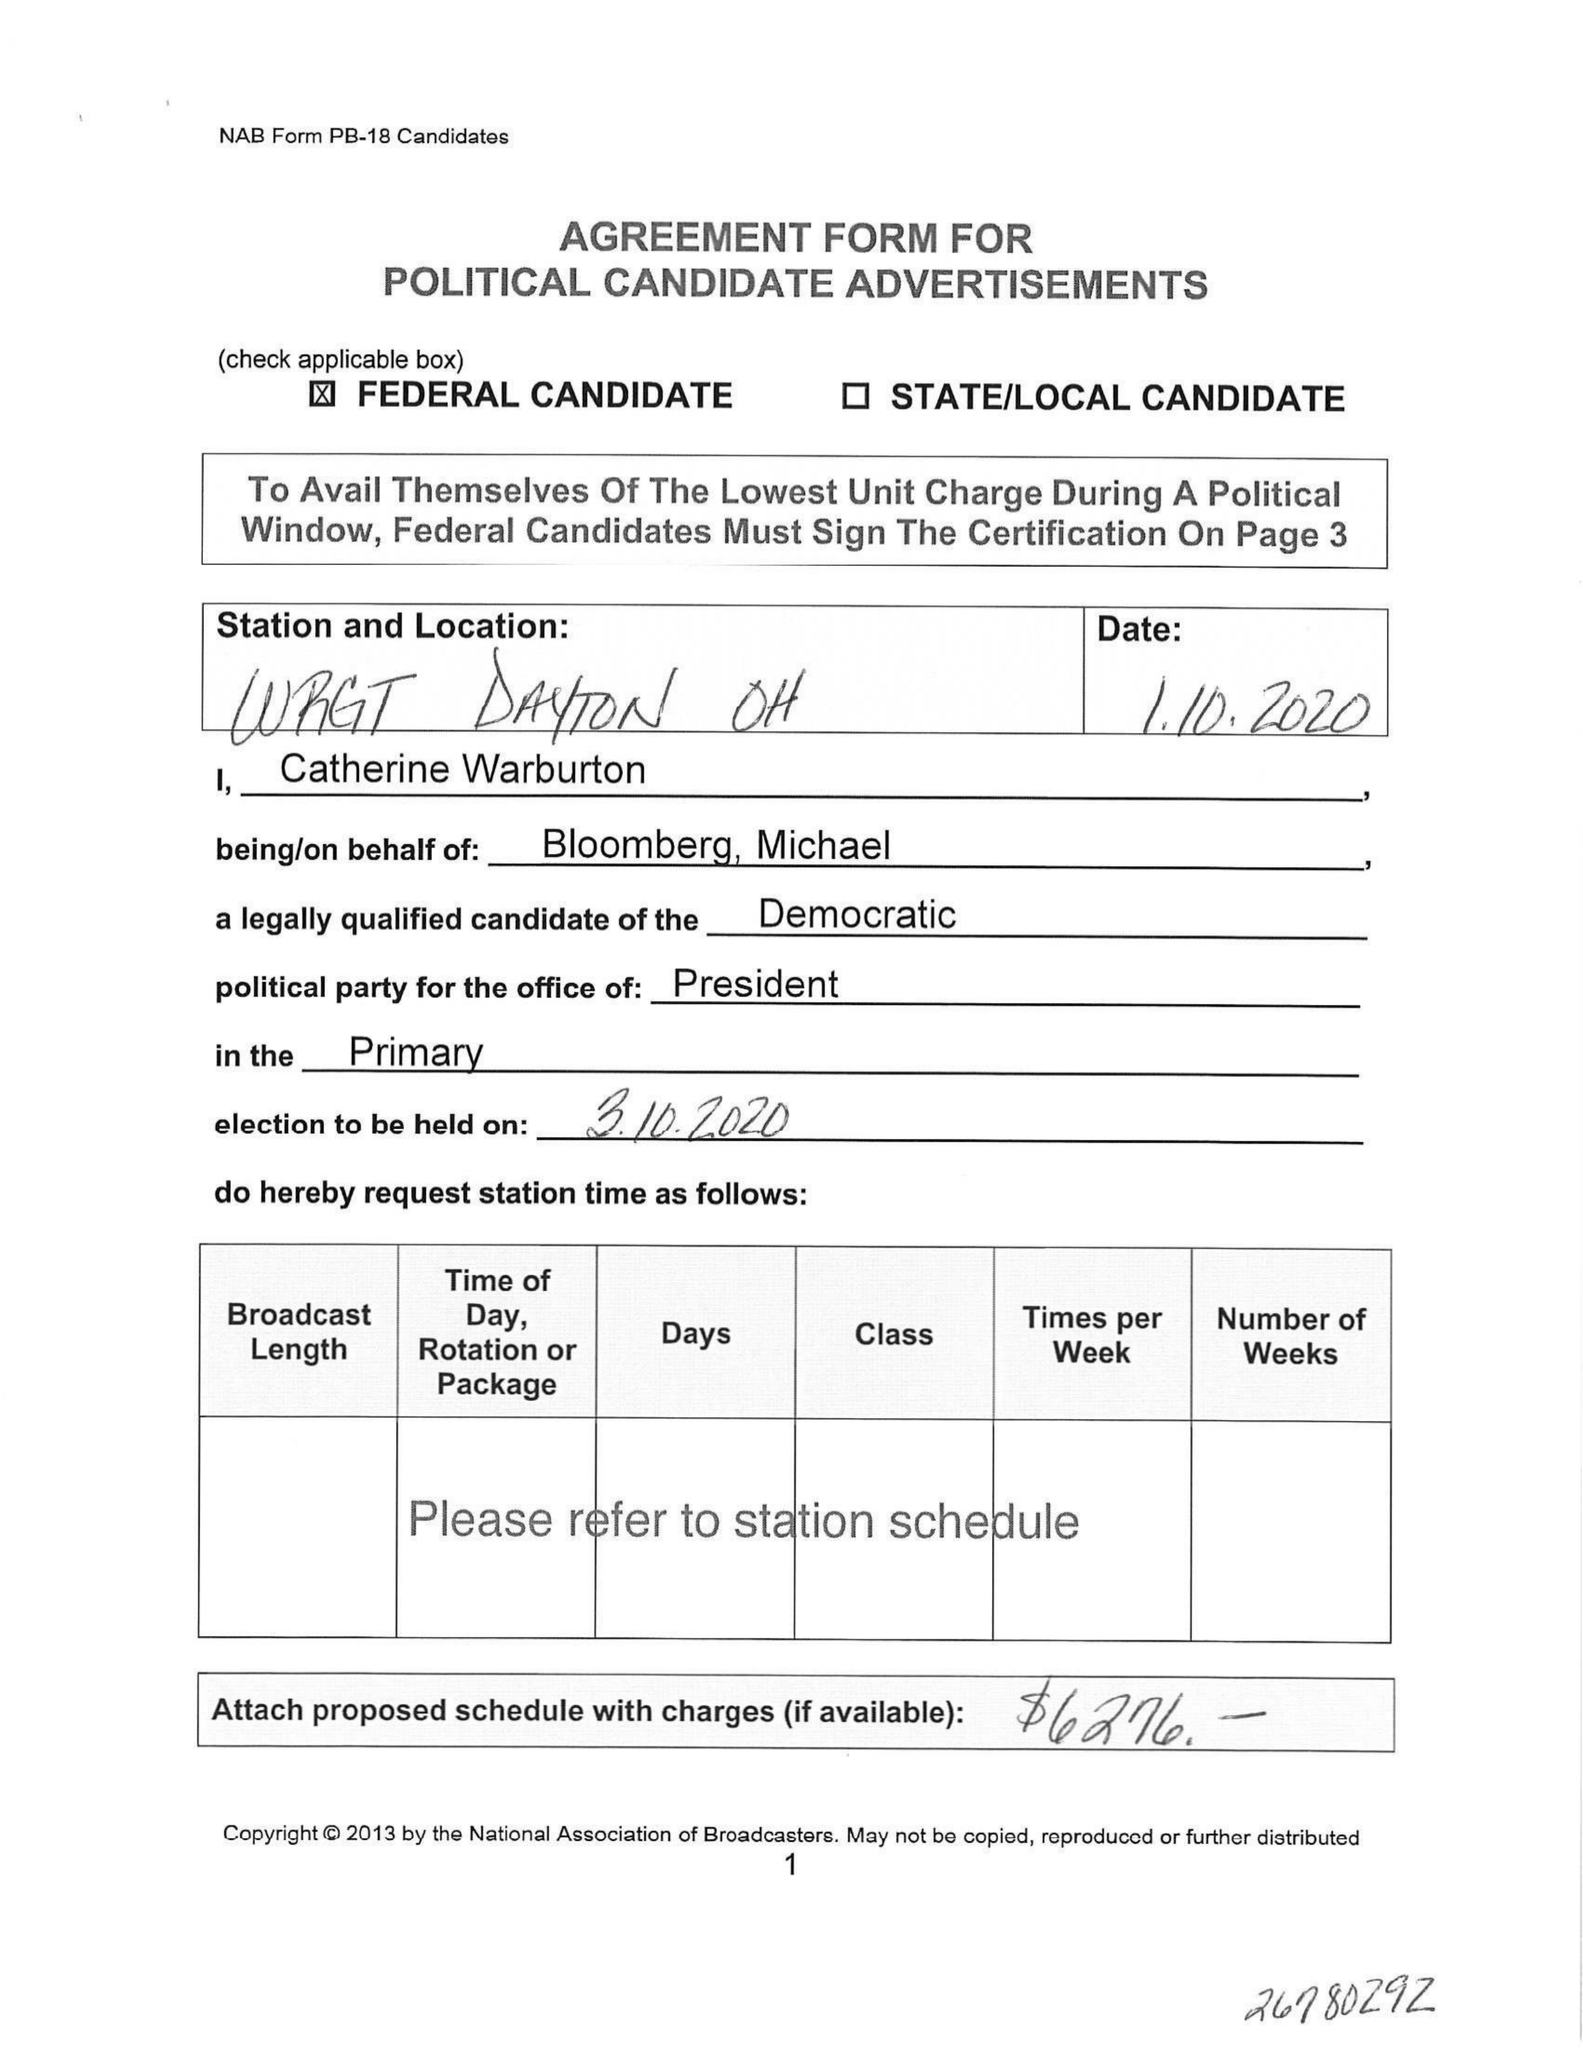What is the value for the flight_to?
Answer the question using a single word or phrase. None 